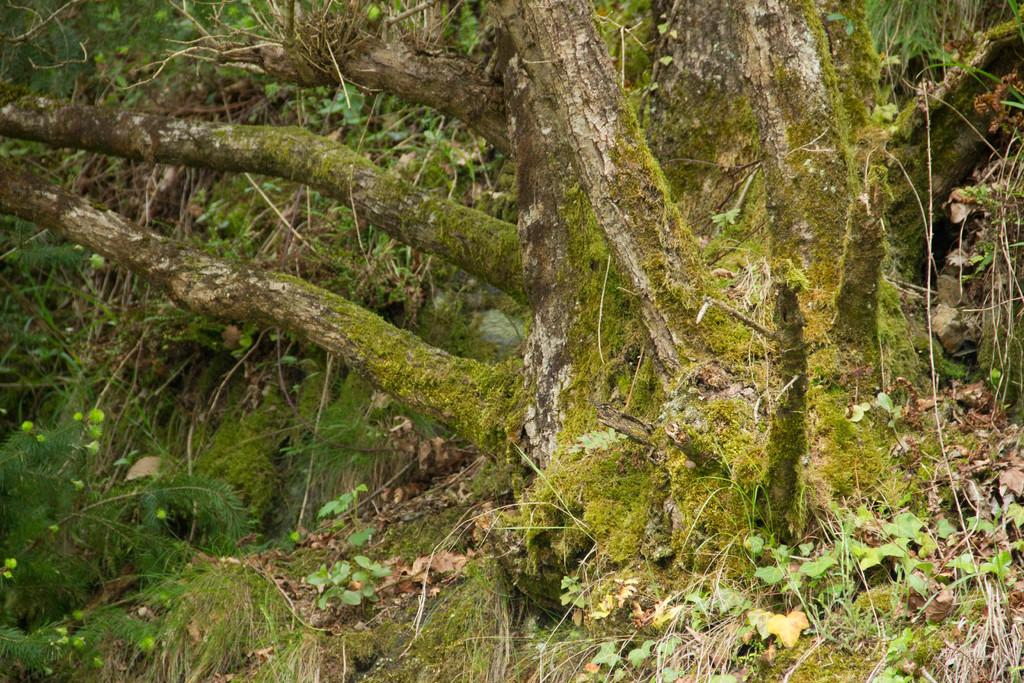What type of vegetation can be seen in the image? There are trees with branches and leaves in the image. Can you describe the main part of the tree in the image? There is a tree trunk visible in the image. What other types of plants are present in the image? Small plants are present in the image. What is the condition of the leaves on the trees in the image? Dried leaves are visible in the image. What time does the clock show in the image? There is no clock present in the image. What is the chance of rain based on the image? The image does not provide any information about the weather or the chance of rain. 